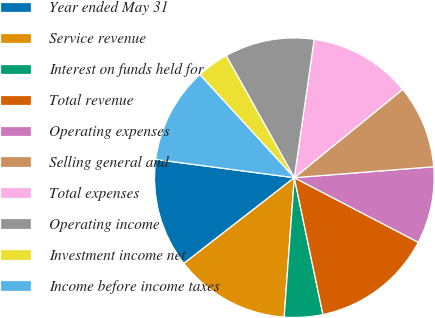<chart> <loc_0><loc_0><loc_500><loc_500><pie_chart><fcel>Year ended May 31<fcel>Service revenue<fcel>Interest on funds held for<fcel>Total revenue<fcel>Operating expenses<fcel>Selling general and<fcel>Total expenses<fcel>Operating income<fcel>Investment income net<fcel>Income before income taxes<nl><fcel>12.59%<fcel>13.33%<fcel>4.44%<fcel>14.07%<fcel>8.89%<fcel>9.63%<fcel>11.85%<fcel>10.37%<fcel>3.7%<fcel>11.11%<nl></chart> 